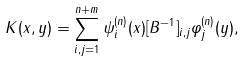<formula> <loc_0><loc_0><loc_500><loc_500>K ( x , y ) = \sum _ { i , j = 1 } ^ { n + m } \psi _ { i } ^ { ( n ) } ( x ) [ B ^ { - 1 } ] _ { i , j } \varphi _ { j } ^ { ( n ) } ( y ) ,</formula> 